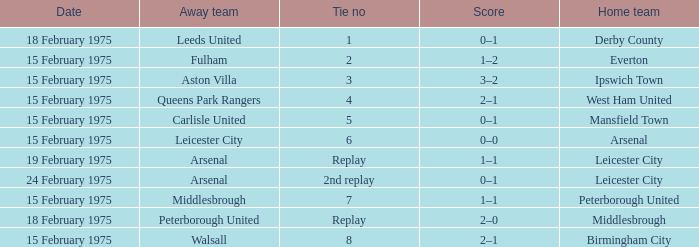What was the tie number when peterborough united was the away team? Replay. 